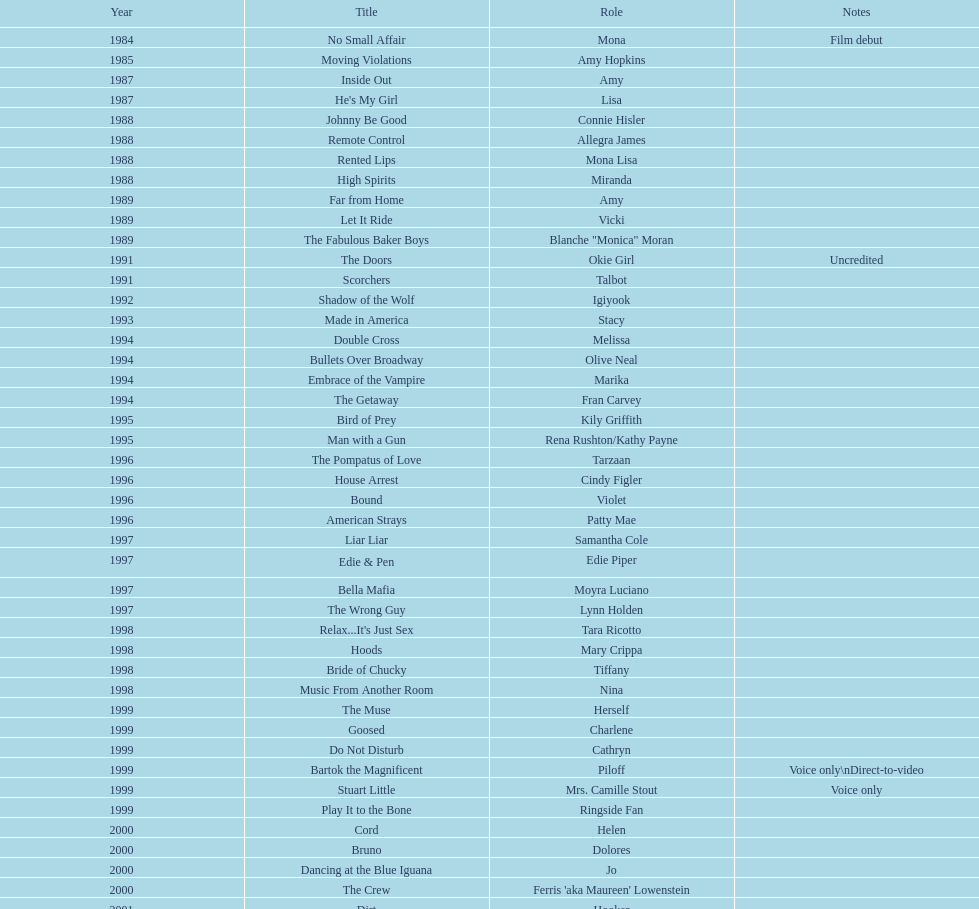Which film was also an acting debut? No Small Affair. 